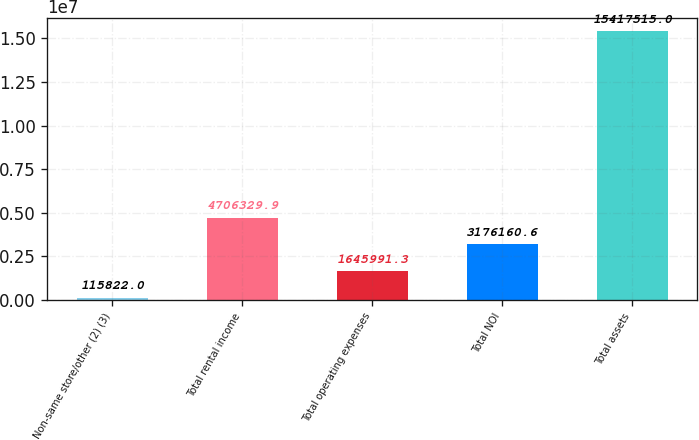Convert chart. <chart><loc_0><loc_0><loc_500><loc_500><bar_chart><fcel>Non-same store/other (2) (3)<fcel>Total rental income<fcel>Total operating expenses<fcel>Total NOI<fcel>Total assets<nl><fcel>115822<fcel>4.70633e+06<fcel>1.64599e+06<fcel>3.17616e+06<fcel>1.54175e+07<nl></chart> 